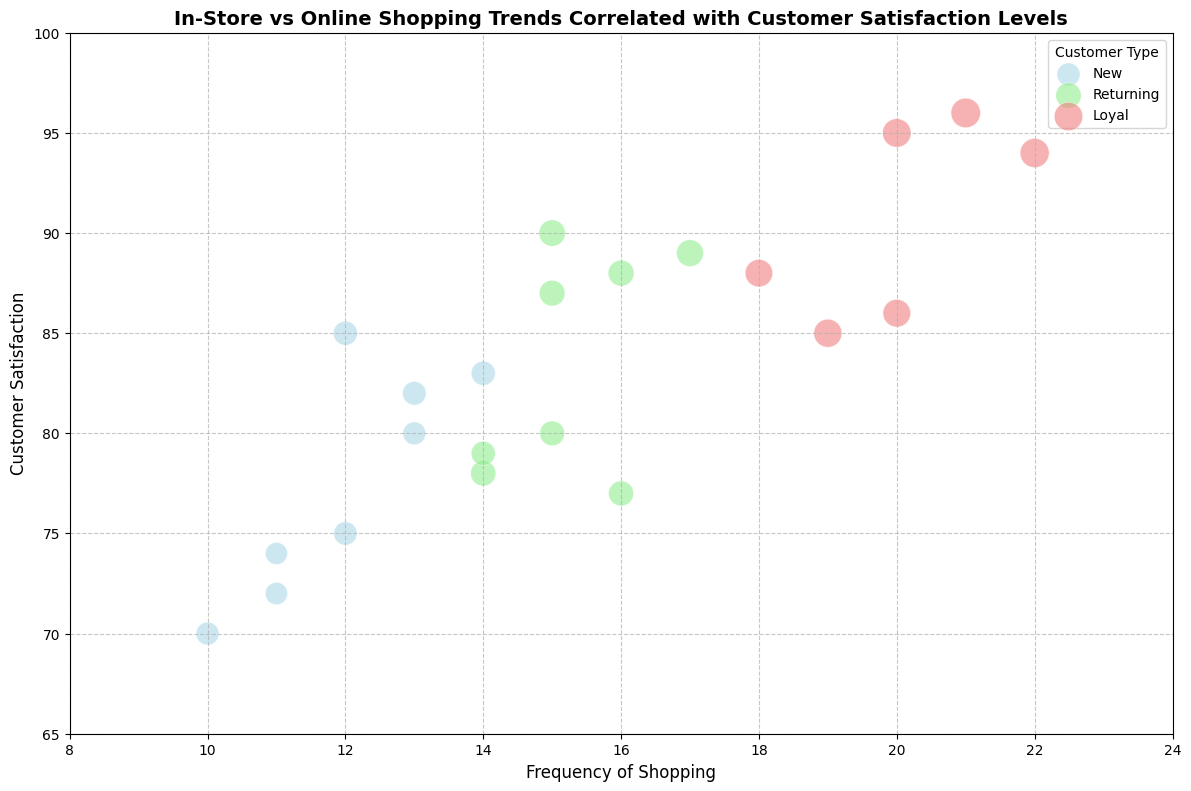What's the highest customer satisfaction among Loyal customers? To determine the highest customer satisfaction among Loyal customers, look for the largest bubble in the "Loyal" category. The highest value can be read directly from the y-axis.
Answer: 96 Which type of customer has the highest average customer satisfaction? To find the customer type with the highest average satisfaction, visually inspect the relative average positions of the bubbles along the y-axis for each customer type. Loyal customers appear to be the highest.
Answer: Loyal Comparing New and Returning customers, who has a higher frequency of shopping on average? Compare the general positions of the bubbles for New and Returning customers along the x-axis. Returning customers' bubbles are generally further to the right.
Answer: Returning Are In-Store shoppers more or less satisfied than Online shoppers on average? Compare the average positions of the In-Store and Online labels' bubbles along the y-axis. Online shoppers' bubbles are generally higher.
Answer: Online Which customer type has the highest average spend per visit, based on bubble size? Look at the relative sizes of the bubbles for different customer types. Larger bubbles indicate higher average spend per visit. Loyal customers have the largest bubbles.
Answer: Loyal Which group, New Online or New In-Store, shows higher satisfaction overall? Compare the vertical positions of the bubbles for New Online and New In-Store customers. New Online bubbles are consistently higher.
Answer: New Online What's the typical range of frequencies of shopping for Loyal Online shoppers? Look at the range of x-axis positions for Loyal Online bubbles. This range falls between approximately 20 and 22.
Answer: 20 to 22 Is there a noticeable difference in spending between Loyal In-Store and Loyal Online shoppers? Compare the sizes of the bubbles for Loyal In-Store and Loyal Online customers. Loyal Online bubbles are generally larger, indicating higher spending.
Answer: Yes Which customer type appears to have the most consistent customer satisfaction? Look for the set of bubbles that appear to align closely in vertical positions. Loyal customers' bubbles are the most closely aligned, indicating consistent satisfaction levels.
Answer: Loyal How does the customer satisfaction of Returning In-Store shoppers compare to that of New Online shoppers? Compare the vertical positions of Returning In-Store and New Online bubbles. New Online bubbles are generally higher, indicating higher satisfaction.
Answer: New Online 